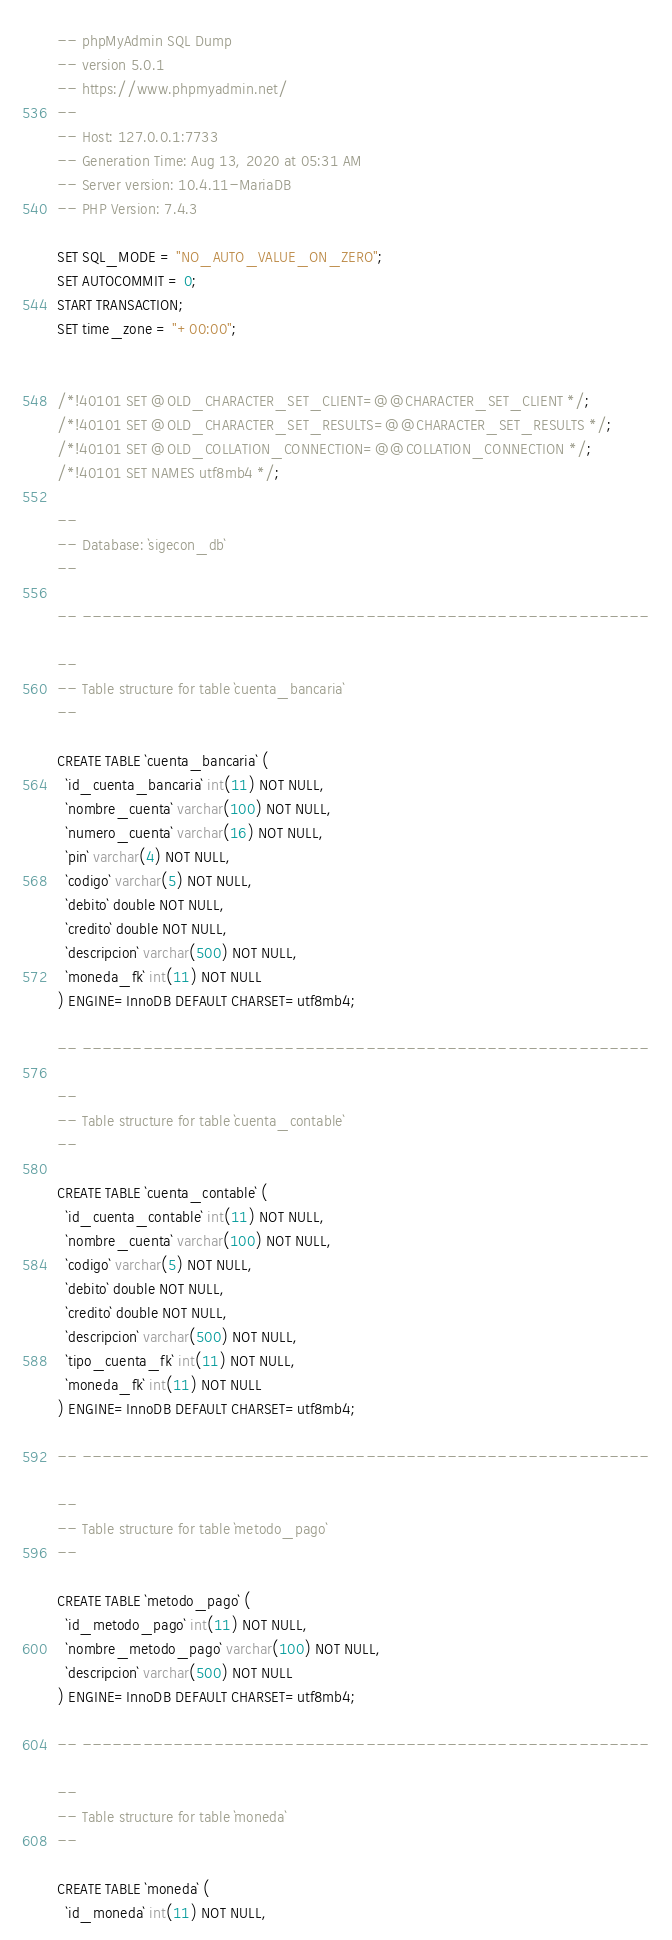Convert code to text. <code><loc_0><loc_0><loc_500><loc_500><_SQL_>-- phpMyAdmin SQL Dump
-- version 5.0.1
-- https://www.phpmyadmin.net/
--
-- Host: 127.0.0.1:7733
-- Generation Time: Aug 13, 2020 at 05:31 AM
-- Server version: 10.4.11-MariaDB
-- PHP Version: 7.4.3

SET SQL_MODE = "NO_AUTO_VALUE_ON_ZERO";
SET AUTOCOMMIT = 0;
START TRANSACTION;
SET time_zone = "+00:00";


/*!40101 SET @OLD_CHARACTER_SET_CLIENT=@@CHARACTER_SET_CLIENT */;
/*!40101 SET @OLD_CHARACTER_SET_RESULTS=@@CHARACTER_SET_RESULTS */;
/*!40101 SET @OLD_COLLATION_CONNECTION=@@COLLATION_CONNECTION */;
/*!40101 SET NAMES utf8mb4 */;

--
-- Database: `sigecon_db`
--

-- --------------------------------------------------------

--
-- Table structure for table `cuenta_bancaria`
--

CREATE TABLE `cuenta_bancaria` (
  `id_cuenta_bancaria` int(11) NOT NULL,
  `nombre_cuenta` varchar(100) NOT NULL,
  `numero_cuenta` varchar(16) NOT NULL,
  `pin` varchar(4) NOT NULL,
  `codigo` varchar(5) NOT NULL,
  `debito` double NOT NULL,
  `credito` double NOT NULL,
  `descripcion` varchar(500) NOT NULL,
  `moneda_fk` int(11) NOT NULL
) ENGINE=InnoDB DEFAULT CHARSET=utf8mb4;

-- --------------------------------------------------------

--
-- Table structure for table `cuenta_contable`
--

CREATE TABLE `cuenta_contable` (
  `id_cuenta_contable` int(11) NOT NULL,
  `nombre_cuenta` varchar(100) NOT NULL,
  `codigo` varchar(5) NOT NULL,
  `debito` double NOT NULL,
  `credito` double NOT NULL,
  `descripcion` varchar(500) NOT NULL,
  `tipo_cuenta_fk` int(11) NOT NULL,
  `moneda_fk` int(11) NOT NULL
) ENGINE=InnoDB DEFAULT CHARSET=utf8mb4;

-- --------------------------------------------------------

--
-- Table structure for table `metodo_pago`
--

CREATE TABLE `metodo_pago` (
  `id_metodo_pago` int(11) NOT NULL,
  `nombre_metodo_pago` varchar(100) NOT NULL,
  `descripcion` varchar(500) NOT NULL
) ENGINE=InnoDB DEFAULT CHARSET=utf8mb4;

-- --------------------------------------------------------

--
-- Table structure for table `moneda`
--

CREATE TABLE `moneda` (
  `id_moneda` int(11) NOT NULL,</code> 